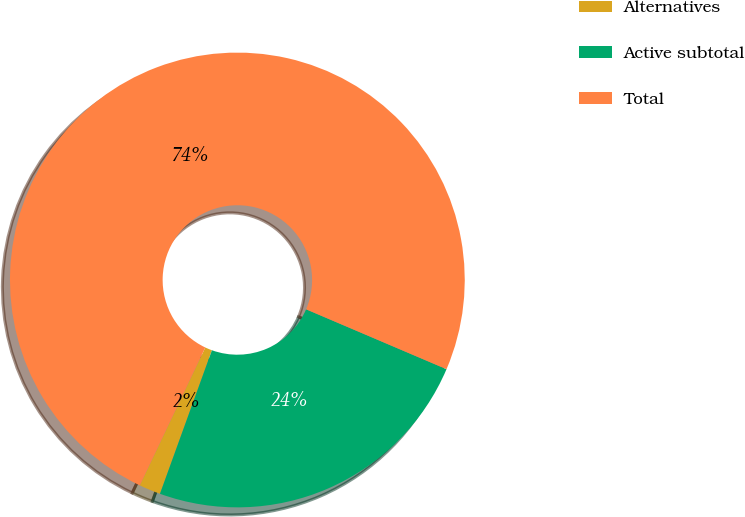Convert chart to OTSL. <chart><loc_0><loc_0><loc_500><loc_500><pie_chart><fcel>Alternatives<fcel>Active subtotal<fcel>Total<nl><fcel>1.53%<fcel>24.11%<fcel>74.36%<nl></chart> 